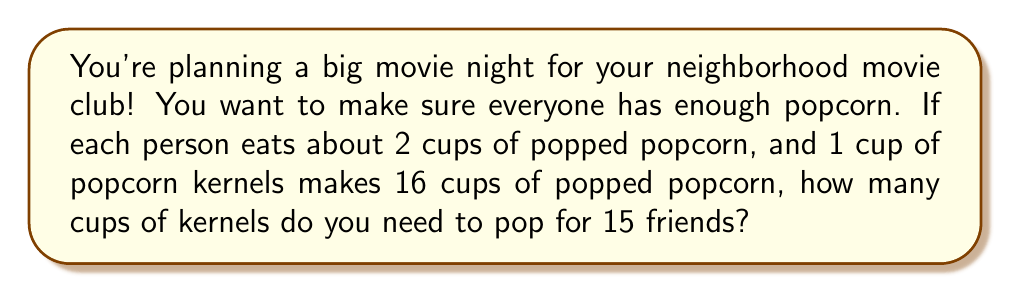Could you help me with this problem? Let's break this down step-by-step:

1. First, calculate how many cups of popped popcorn you need in total:
   * Each person eats 2 cups of popped popcorn
   * There are 15 friends
   * Total popped popcorn needed = $15 \times 2 = 30$ cups

2. Now, we need to find out how many cups of kernels are needed to make 30 cups of popped popcorn:
   * 1 cup of kernels makes 16 cups of popped popcorn
   * Let $x$ be the number of cups of kernels needed
   * We can set up the equation: $16x = 30$

3. Solve for $x$:
   $$x = \frac{30}{16} = 1.875$$

4. Round up to the nearest quarter cup to ensure you have enough:
   $1.875$ rounds up to $2$ cups

This means you need 2 cups of kernels to make enough popcorn for all your friends.
Answer: 2 cups of popcorn kernels 